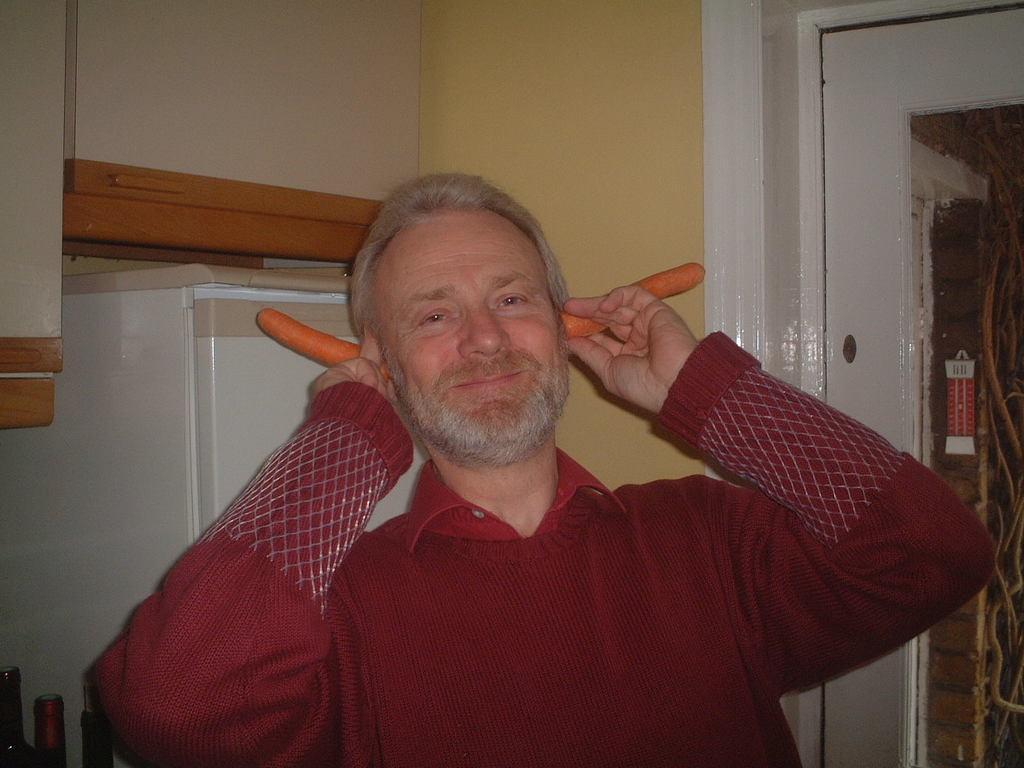Could you give a brief overview of what you see in this image? In the middle of this image, there is a person in red color shirt, holding two carrots with both hands and keeping them in the two years and smiling. On the right side, there is a glass door, on which there is a sticker pasted. On the left side, there is a white color refrigerator. Beside this refrigerator, there is a wall. 